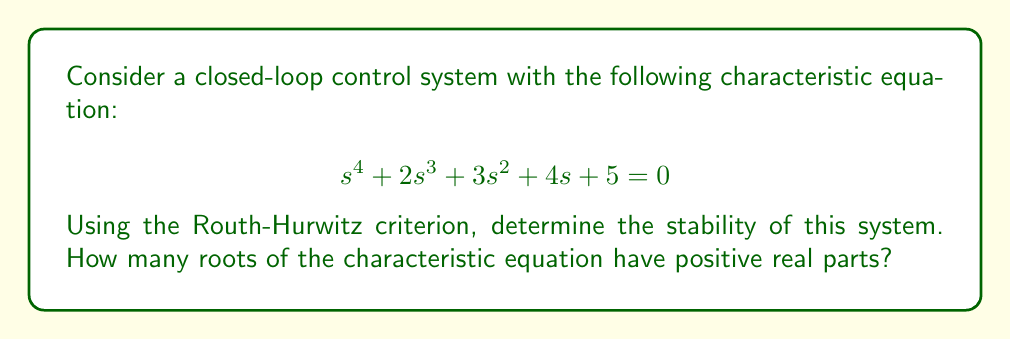Can you answer this question? To analyze the stability of the system using the Routh-Hurwitz criterion, we need to construct the Routh array and examine the signs of the first column. Let's go through this step-by-step:

1. Construct the Routh array:

   $$\begin{array}{c|cccc}
   s^4 & 1 & 3 & 5 \\
   s^3 & 2 & 4 & 0 \\
   s^2 & b_1 & b_2 & \\
   s^1 & c_1 & & \\
   s^0 & d_1 & &
   \end{array}$$

2. Calculate the values for the lower rows:

   $b_1 = \frac{(2)(3) - (1)(4)}{2} = 1$
   
   $b_2 = \frac{(2)(5) - (1)(0)}{2} = 5$
   
   $c_1 = \frac{(1)(4) - (2)(5)}{1} = -6$
   
   $d_1 = 5$ (as $b_2 = 5$)

3. The complete Routh array:

   $$\begin{array}{c|cccc}
   s^4 & 1 & 3 & 5 \\
   s^3 & 2 & 4 & 0 \\
   s^2 & 1 & 5 & \\
   s^1 & -6 & & \\
   s^0 & 5 & &
   \end{array}$$

4. Examine the signs in the first column:
   We see that there is one sign change in the first column (from 1 to -6).

5. According to the Routh-Hurwitz criterion, the number of sign changes in the first column of the Routh array equals the number of roots with positive real parts.

Therefore, the system has one root with a positive real part, indicating that it is unstable.
Answer: The system is unstable, with 1 root having a positive real part. 